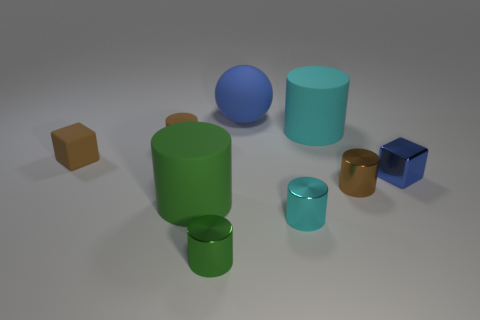Subtract all big cyan matte cylinders. How many cylinders are left? 5 Add 1 blue objects. How many objects exist? 10 Subtract all brown cubes. How many cubes are left? 1 Subtract all balls. How many objects are left? 8 Subtract 3 cylinders. How many cylinders are left? 3 Subtract all green spheres. Subtract all cyan cylinders. How many spheres are left? 1 Subtract all green blocks. How many red spheres are left? 0 Subtract all large cyan blocks. Subtract all tiny shiny blocks. How many objects are left? 8 Add 6 tiny brown metal cylinders. How many tiny brown metal cylinders are left? 7 Add 8 brown matte blocks. How many brown matte blocks exist? 9 